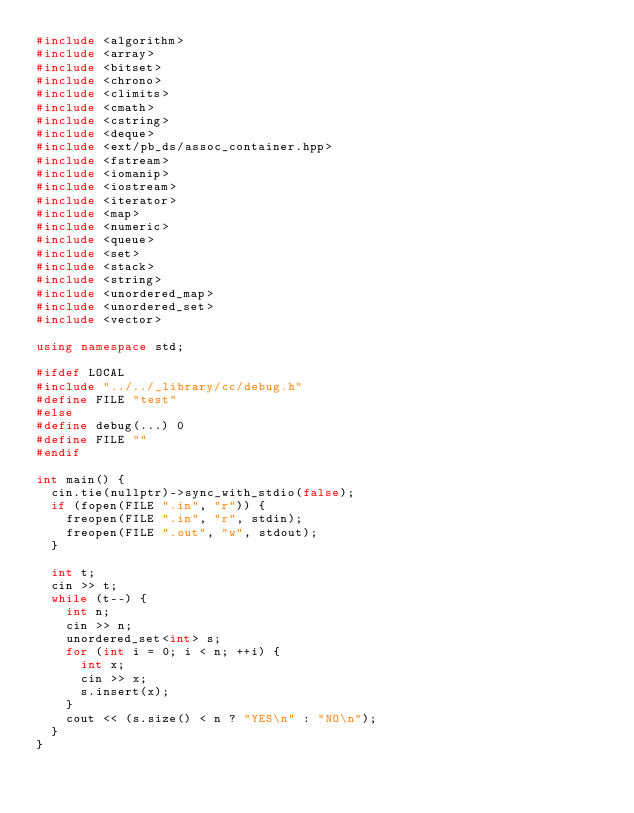<code> <loc_0><loc_0><loc_500><loc_500><_C++_>#include <algorithm>
#include <array>
#include <bitset>
#include <chrono>
#include <climits>
#include <cmath>
#include <cstring>
#include <deque>
#include <ext/pb_ds/assoc_container.hpp>
#include <fstream>
#include <iomanip>
#include <iostream>
#include <iterator>
#include <map>
#include <numeric>
#include <queue>
#include <set>
#include <stack>
#include <string>
#include <unordered_map>
#include <unordered_set>
#include <vector>

using namespace std;

#ifdef LOCAL
#include "../../_library/cc/debug.h"
#define FILE "test"
#else
#define debug(...) 0
#define FILE ""
#endif

int main() {
  cin.tie(nullptr)->sync_with_stdio(false);
  if (fopen(FILE ".in", "r")) {
    freopen(FILE ".in", "r", stdin);
    freopen(FILE ".out", "w", stdout);
  }

  int t;
  cin >> t;
  while (t--) {
    int n;
    cin >> n;
    unordered_set<int> s;
    for (int i = 0; i < n; ++i) {
      int x;
      cin >> x;
      s.insert(x);
    }
    cout << (s.size() < n ? "YES\n" : "NO\n");
  }
}
</code> 